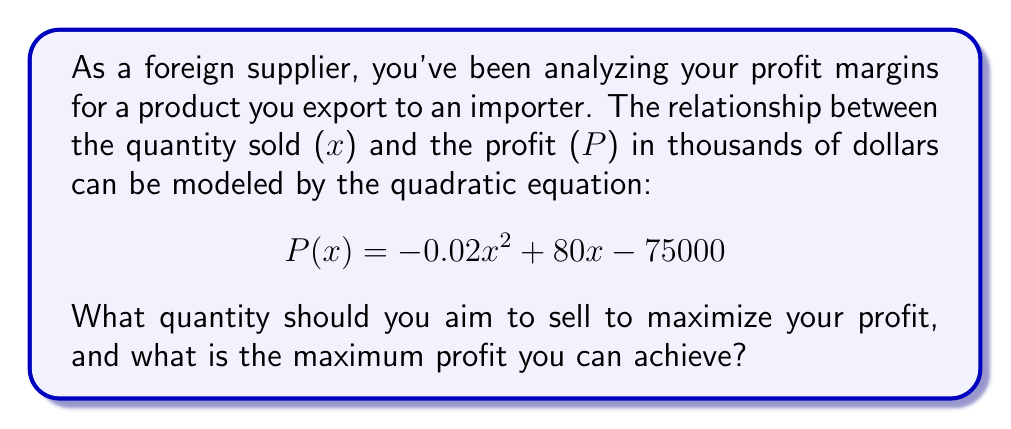Help me with this question. To find the maximum profit and the quantity that yields it, we need to follow these steps:

1) The profit function is a quadratic equation in the form $P(x) = ax^2 + bx + c$, where:
   $a = -0.02$
   $b = 80$
   $c = -75000$

2) For a quadratic function, the x-coordinate of the vertex represents the value of x that maximizes (or minimizes) the function. We can find this using the formula:

   $x = -\frac{b}{2a}$

3) Substituting our values:

   $x = -\frac{80}{2(-0.02)} = \frac{80}{0.04} = 2000$

4) This means that selling 2000 units will maximize the profit.

5) To find the maximum profit, we substitute x = 2000 into our original equation:

   $P(2000) = -0.02(2000)^2 + 80(2000) - 75000$
   
   $= -0.02(4000000) + 160000 - 75000$
   
   $= -80000 + 160000 - 75000$
   
   $= 5000$

6) Therefore, the maximum profit is $5000 thousand, or $5 million.
Answer: 2000 units; $5 million 